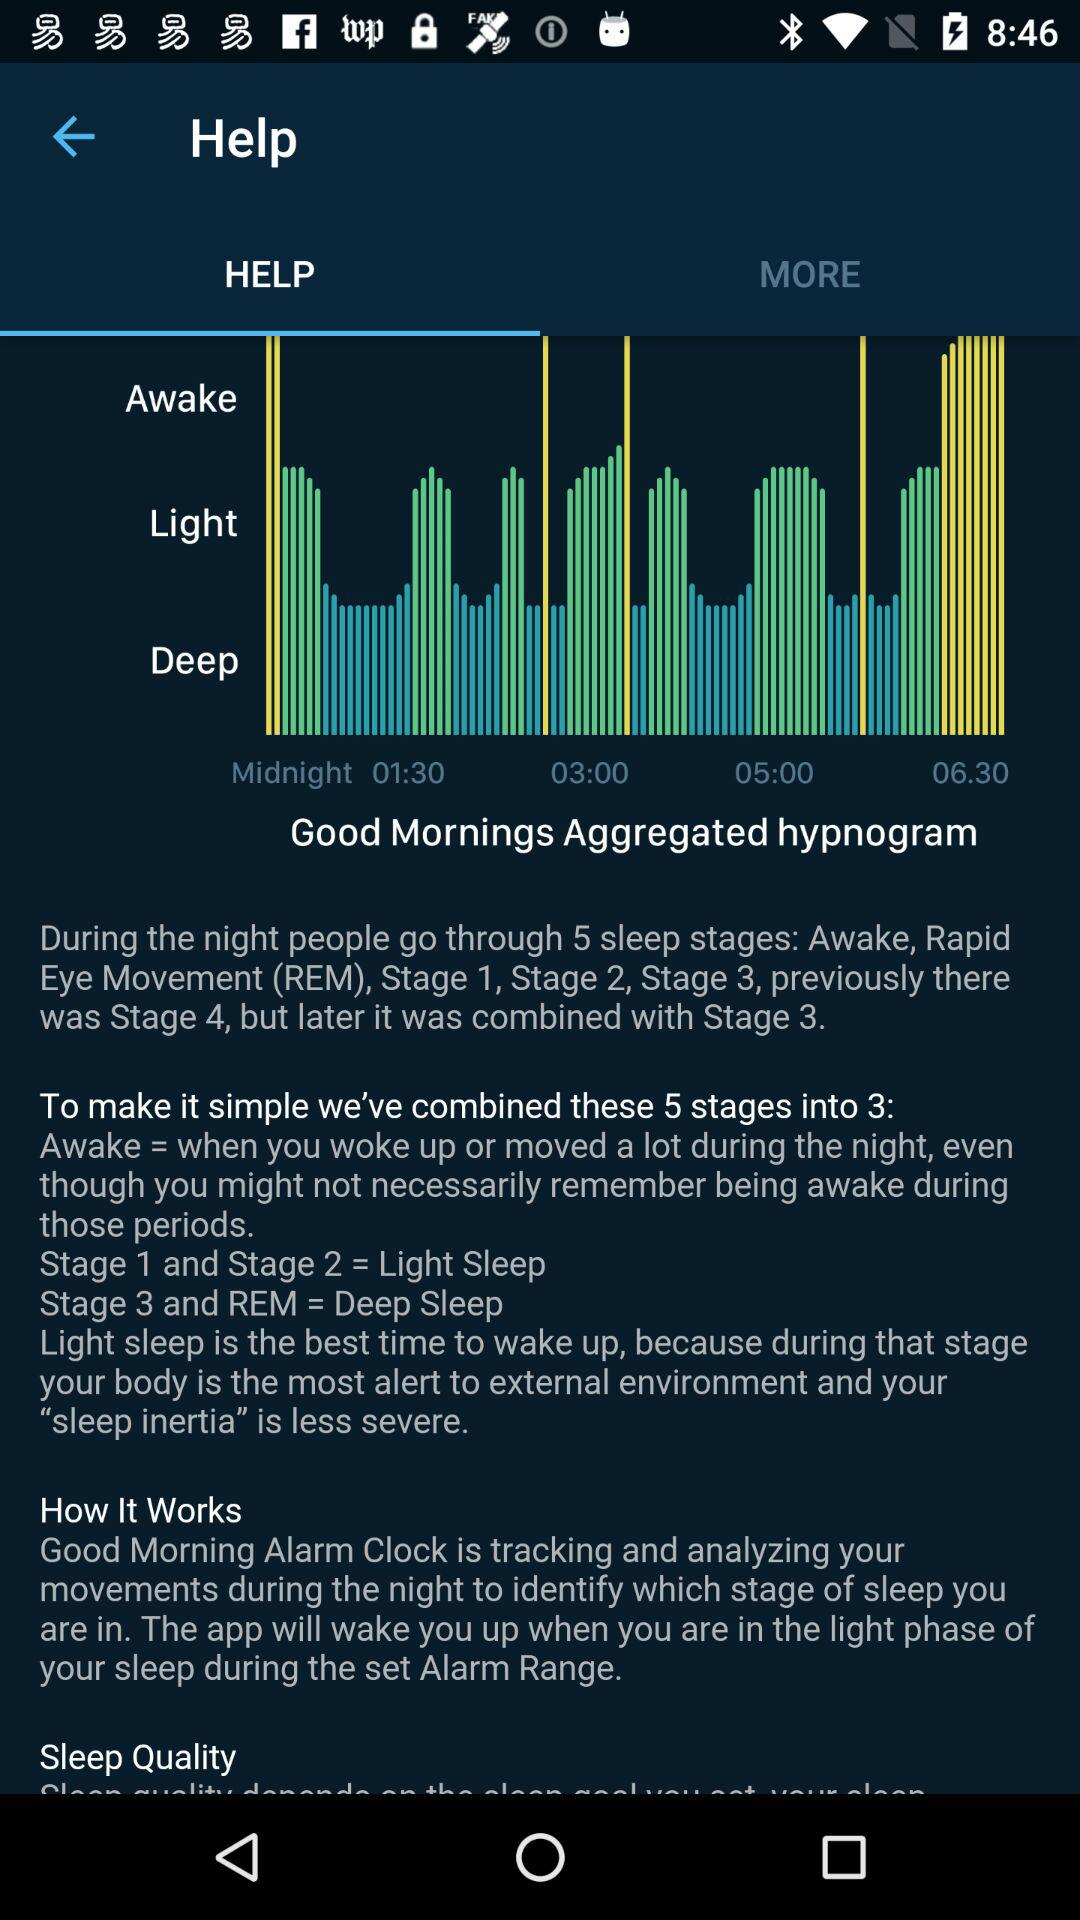What is the type of sleep in "Stage 1 and Stage 2"? The type is "Light Sleep". 